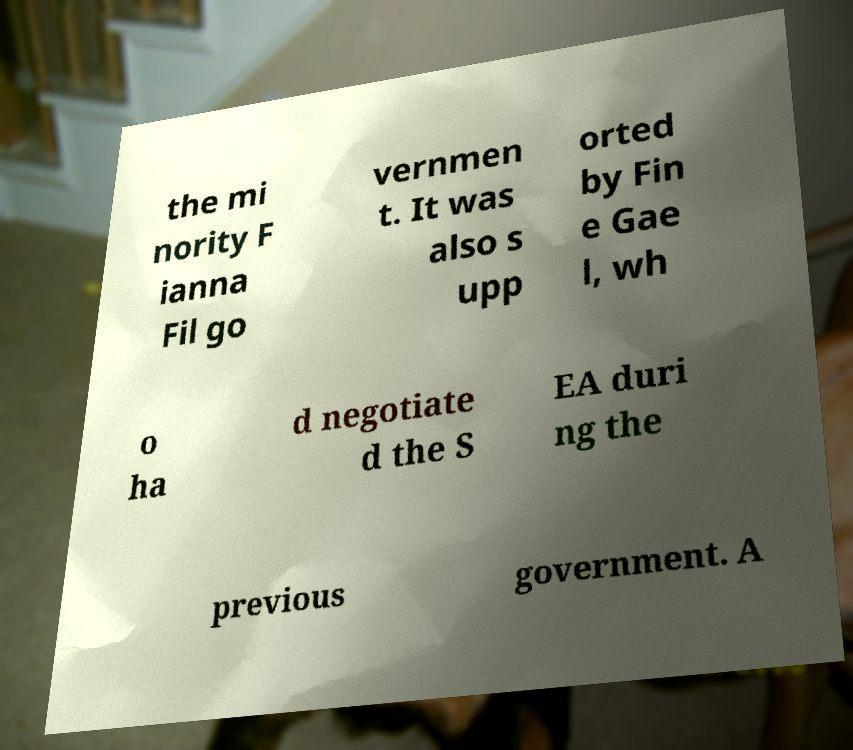Could you extract and type out the text from this image? the mi nority F ianna Fil go vernmen t. It was also s upp orted by Fin e Gae l, wh o ha d negotiate d the S EA duri ng the previous government. A 